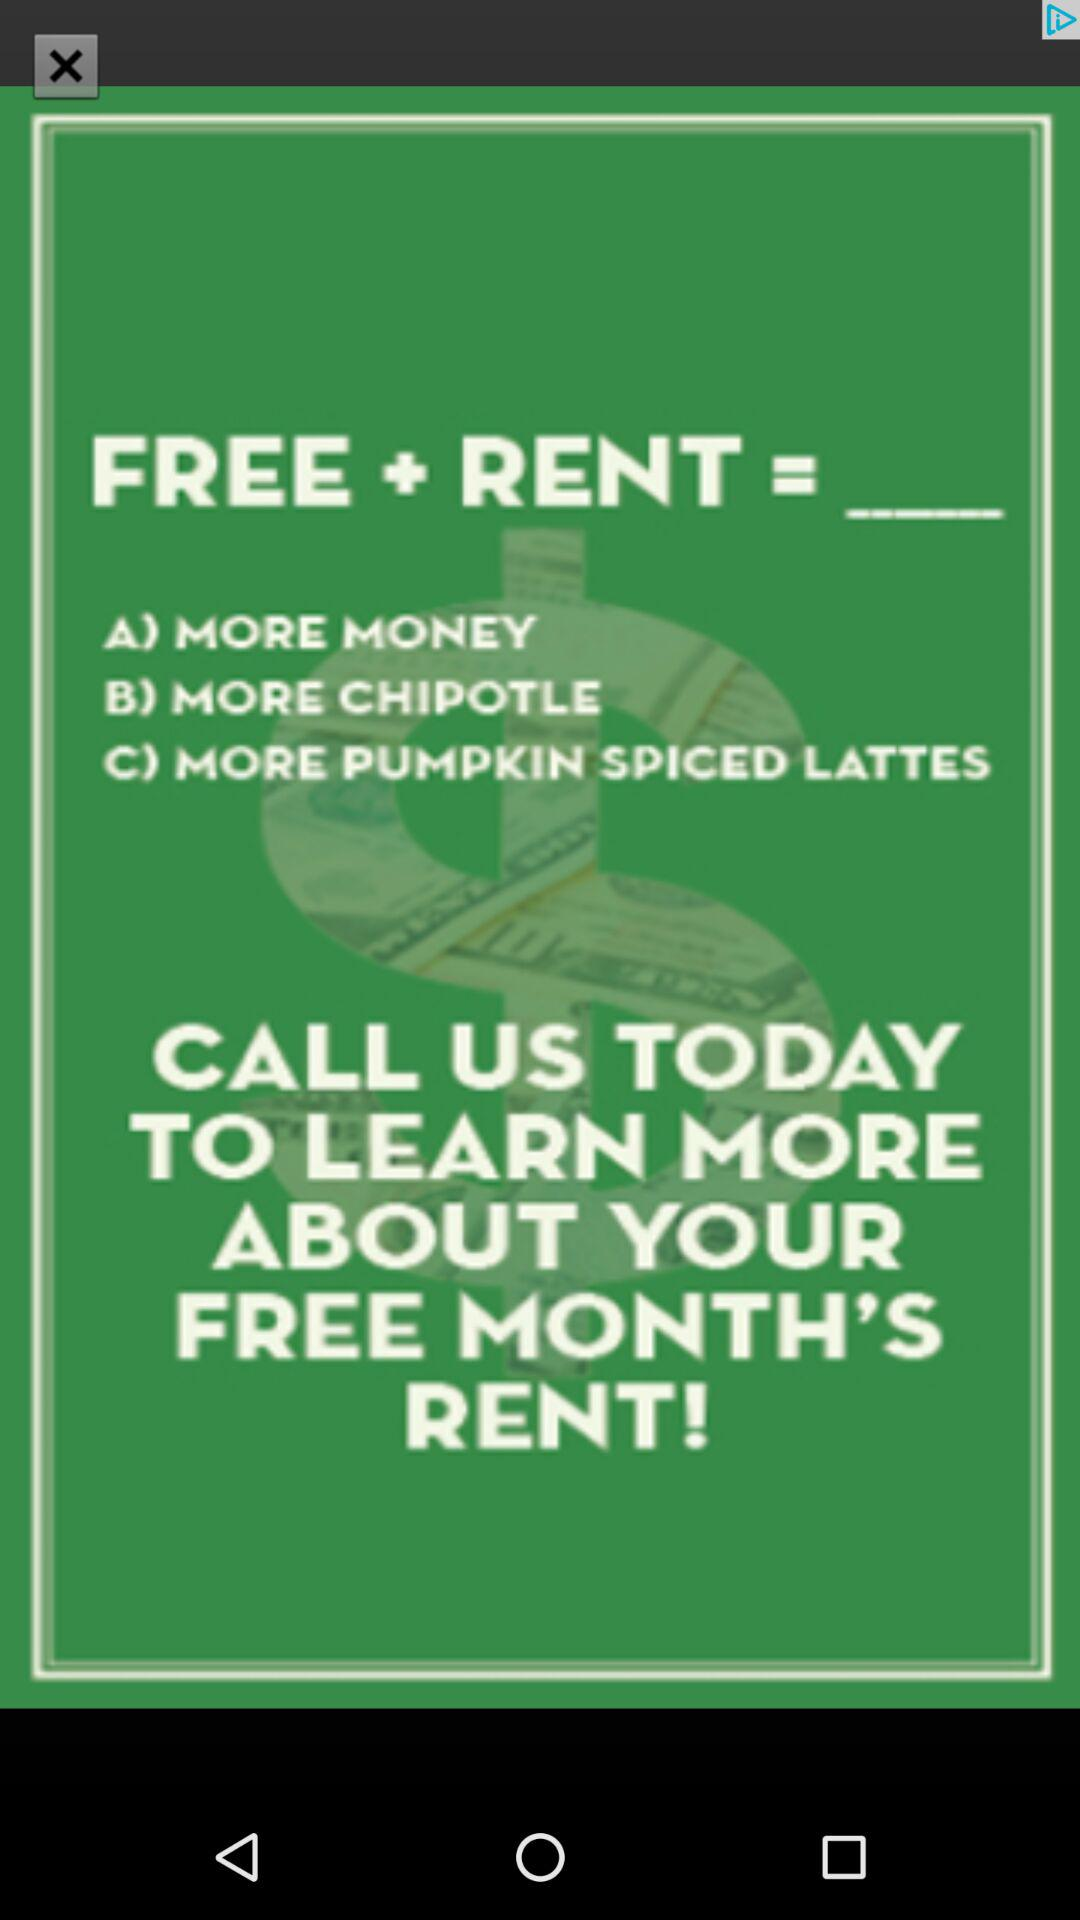How many text options are there?
Answer the question using a single word or phrase. 3 